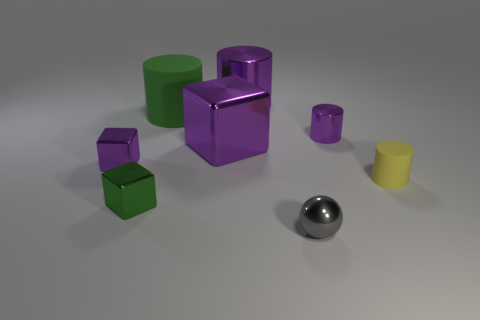Add 1 small cylinders. How many objects exist? 9 Subtract all spheres. How many objects are left? 7 Add 1 tiny brown blocks. How many tiny brown blocks exist? 1 Subtract 1 green blocks. How many objects are left? 7 Subtract all cubes. Subtract all tiny metal blocks. How many objects are left? 3 Add 8 small gray spheres. How many small gray spheres are left? 9 